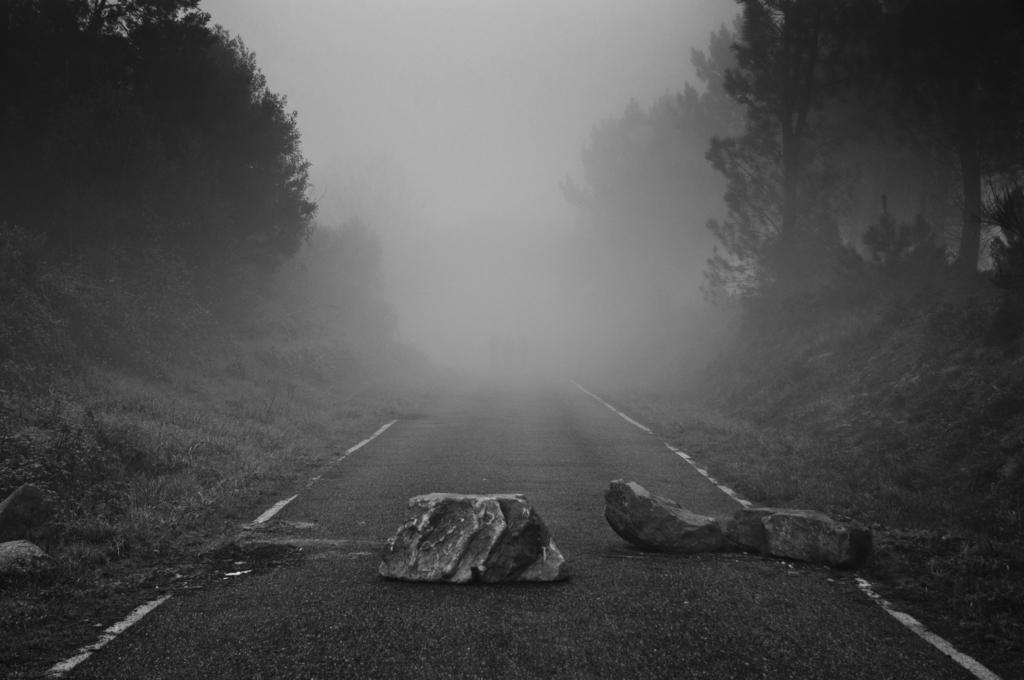What can be seen on the road in the image? There are stones on the road in the image. What is visible in the background of the image? There are trees and fog visible in the background of the image. What type of start can be seen in the image? There is no start present in the image; it features stones on the road and trees and fog in the background. Can you tell me how many beetles are crawling on the stones in the image? There are no beetles present in the image; it only shows stones on the road, trees in the background, and fog. 